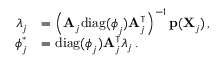<formula> <loc_0><loc_0><loc_500><loc_500>\begin{array} { r l } { \lambda _ { j } } & { = \left ( A _ { j } d i a g ( \phi _ { j } ) A _ { j } ^ { \intercal } \right ) ^ { - 1 } p ( X _ { j } ) \, , } \\ { \phi _ { j } ^ { \ast } } & { = d i a g ( \phi _ { j } ) A _ { j } ^ { \intercal } \lambda _ { j } \, . } \end{array}</formula> 